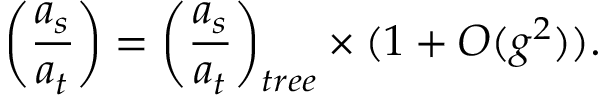Convert formula to latex. <formula><loc_0><loc_0><loc_500><loc_500>\left ( { \frac { a _ { s } } { a _ { t } } } \right ) = \left ( { \frac { a _ { s } } { a _ { t } } } \right ) _ { t r e e } \times ( 1 + O ( g ^ { 2 } ) ) .</formula> 